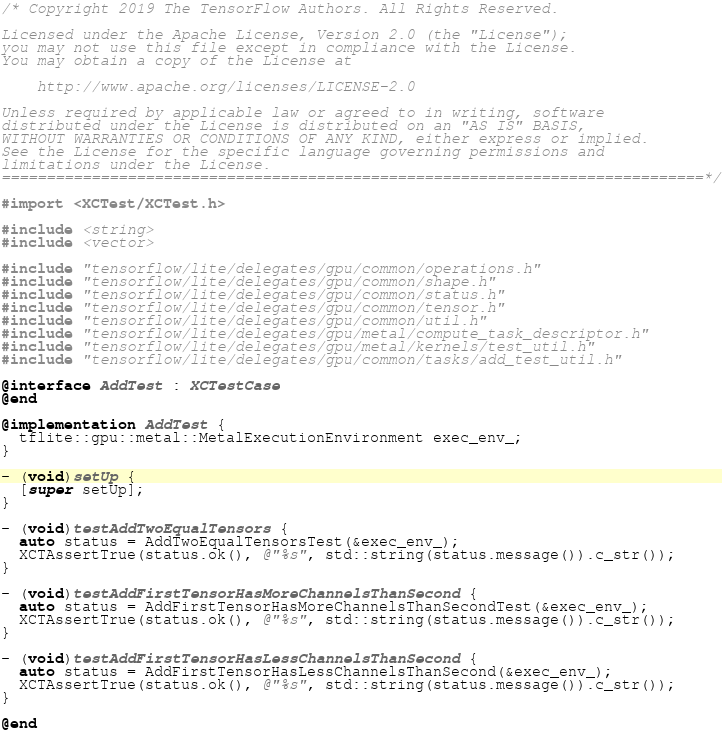Convert code to text. <code><loc_0><loc_0><loc_500><loc_500><_ObjectiveC_>/* Copyright 2019 The TensorFlow Authors. All Rights Reserved.

Licensed under the Apache License, Version 2.0 (the "License");
you may not use this file except in compliance with the License.
You may obtain a copy of the License at

    http://www.apache.org/licenses/LICENSE-2.0

Unless required by applicable law or agreed to in writing, software
distributed under the License is distributed on an "AS IS" BASIS,
WITHOUT WARRANTIES OR CONDITIONS OF ANY KIND, either express or implied.
See the License for the specific language governing permissions and
limitations under the License.
==============================================================================*/

#import <XCTest/XCTest.h>

#include <string>
#include <vector>

#include "tensorflow/lite/delegates/gpu/common/operations.h"
#include "tensorflow/lite/delegates/gpu/common/shape.h"
#include "tensorflow/lite/delegates/gpu/common/status.h"
#include "tensorflow/lite/delegates/gpu/common/tensor.h"
#include "tensorflow/lite/delegates/gpu/common/util.h"
#include "tensorflow/lite/delegates/gpu/metal/compute_task_descriptor.h"
#include "tensorflow/lite/delegates/gpu/metal/kernels/test_util.h"
#include "tensorflow/lite/delegates/gpu/common/tasks/add_test_util.h"

@interface AddTest : XCTestCase
@end

@implementation AddTest {
  tflite::gpu::metal::MetalExecutionEnvironment exec_env_;
}

- (void)setUp {
  [super setUp];
}

- (void)testAddTwoEqualTensors {
  auto status = AddTwoEqualTensorsTest(&exec_env_);
  XCTAssertTrue(status.ok(), @"%s", std::string(status.message()).c_str());
}

- (void)testAddFirstTensorHasMoreChannelsThanSecond {
  auto status = AddFirstTensorHasMoreChannelsThanSecondTest(&exec_env_);
  XCTAssertTrue(status.ok(), @"%s", std::string(status.message()).c_str());
}

- (void)testAddFirstTensorHasLessChannelsThanSecond {
  auto status = AddFirstTensorHasLessChannelsThanSecond(&exec_env_);
  XCTAssertTrue(status.ok(), @"%s", std::string(status.message()).c_str());
}

@end
</code> 